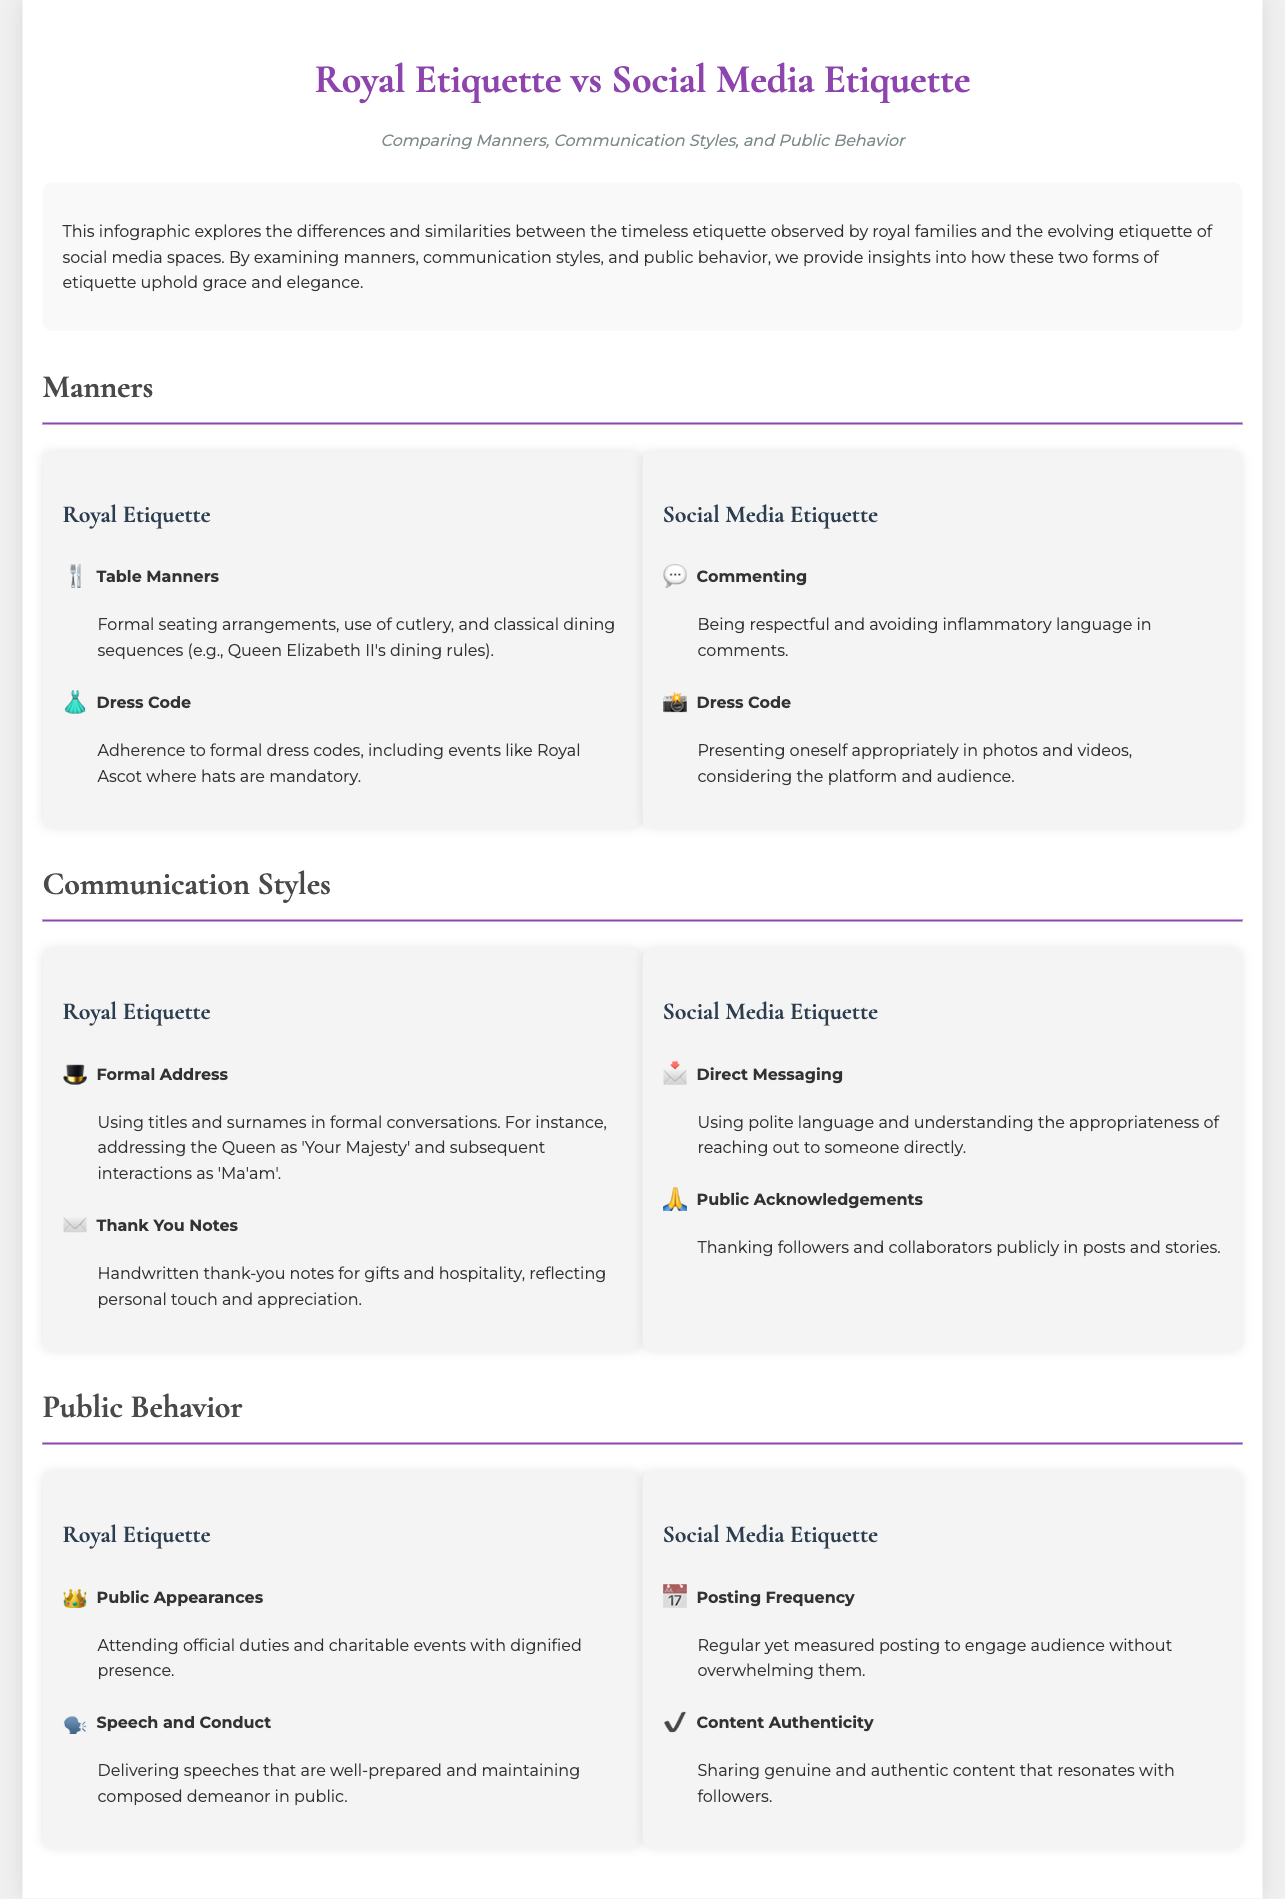what are the two main aspects compared in the infographic? The infographic compares Royal Etiquette and Social Media Etiquette.
Answer: Royal Etiquette and Social Media Etiquette which icon represents Table Manners in Royal Etiquette? The icon representing Table Manners is a fork and knife emoji.
Answer: 🍴 how are Direction Messaging and Thank You Notes similar in their etiquette? Both require polite language and appreciation.
Answer: Polite language and appreciation what is the dress code requirement for Royal Ascot? The document states that hats are mandatory during the event.
Answer: Hats are mandatory how should public acknowledgments be made in Social Media Etiquette? Public acknowledgments should thank followers and collaborators publicly.
Answer: Publicly thank followers and collaborators what does the Royal Etiquette recommend for public appearances? It recommends attending official duties and charitable events with a dignified presence.
Answer: Dignified presence how often should social media posts be made according to Social Media Etiquette? The infographic advises regular yet measured posting frequency.
Answer: Regular yet measured which term is used to describe the conduct during public speeches in Royal Etiquette? The document refers to it simply as conduct, specifically focusing on a composed demeanor.
Answer: Composed demeanor 